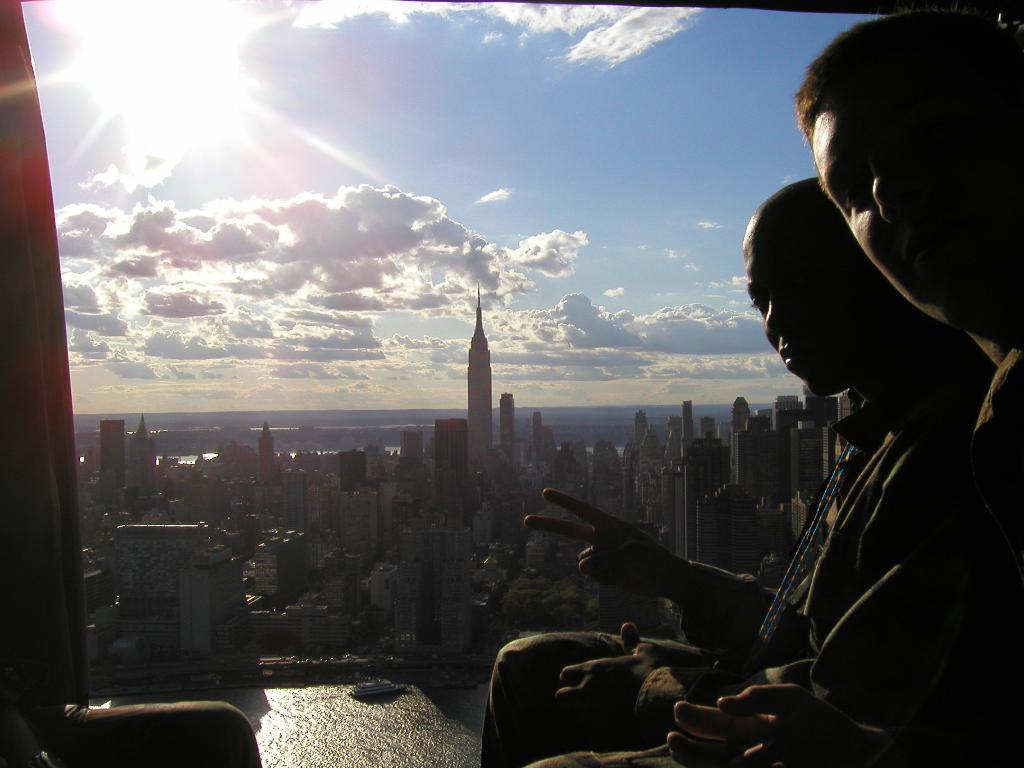Describe this image in one or two sentences. On the right side, we see two men are sitting and they are posing. At the bottom, we see water and this water might be in the lake. There are buildings in the background. At the top, we see the sky, clouds and the sun. 